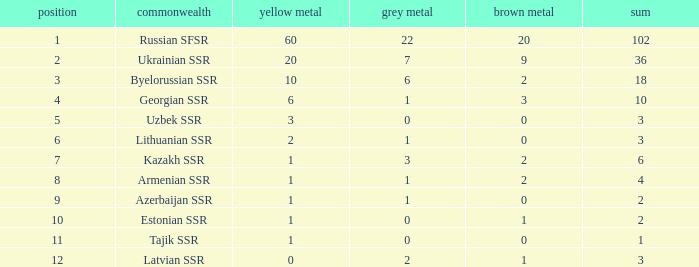What is the sum of silvers for teams with ranks over 3 and totals under 2? 0.0. 